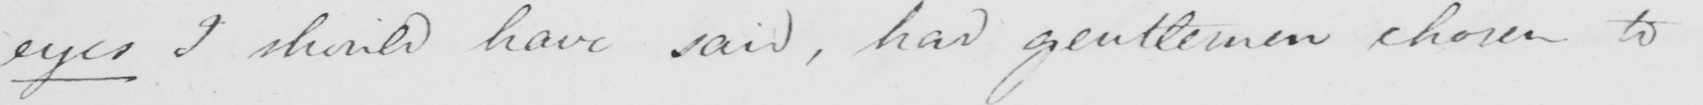What does this handwritten line say? eyes I should have said , had gentlemen chosen to 